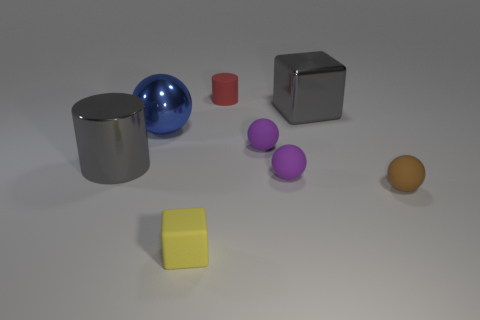Can you infer the sizes of these objects relative to one another? Relative sizes suggest the gray cylinder and the blue sphere are the largest, followed by the silver cube. The red cube and the yellow cube are intermediate in size, whereas the purple spheres are the smallest objects present. 